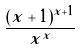Convert formula to latex. <formula><loc_0><loc_0><loc_500><loc_500>\frac { ( x + 1 ) ^ { x + 1 } } { x ^ { x } }</formula> 